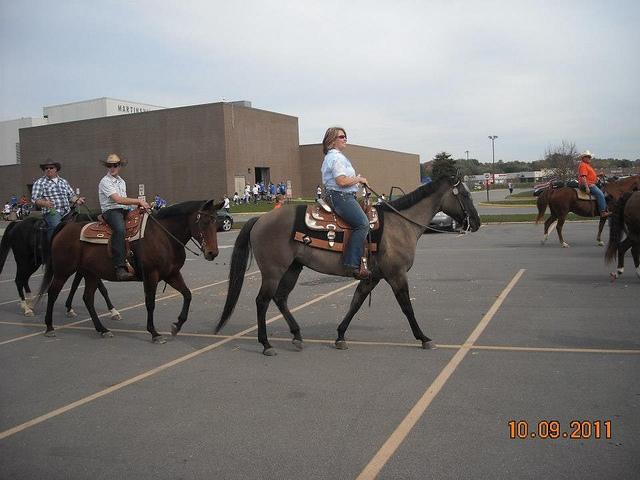How many horses are in the street?
Quick response, please. 5. Who are on the horses?
Answer briefly. People. What year was this picture taken?
Give a very brief answer. 2011. What is the horses' job?
Give a very brief answer. Entertainment. Would these creatures be likely to rear if this sky suddenly produced lightning?
Give a very brief answer. Yes. What year was this photo taken?
Keep it brief. 2011. Is this a parade?
Answer briefly. No. How many awnings are visible?
Quick response, please. 0. What color is the first horse?
Write a very short answer. Gray. Who is riding the horses?
Concise answer only. People. How many animals are there?
Answer briefly. 5. What type of people are riding the horses?
Concise answer only. Woman. How many hooves does the animal have on the ground right now in photo?
Quick response, please. 4. What is the guy on the left wearing on his head?
Write a very short answer. Hat. What animals are shown?
Quick response, please. Horses. 